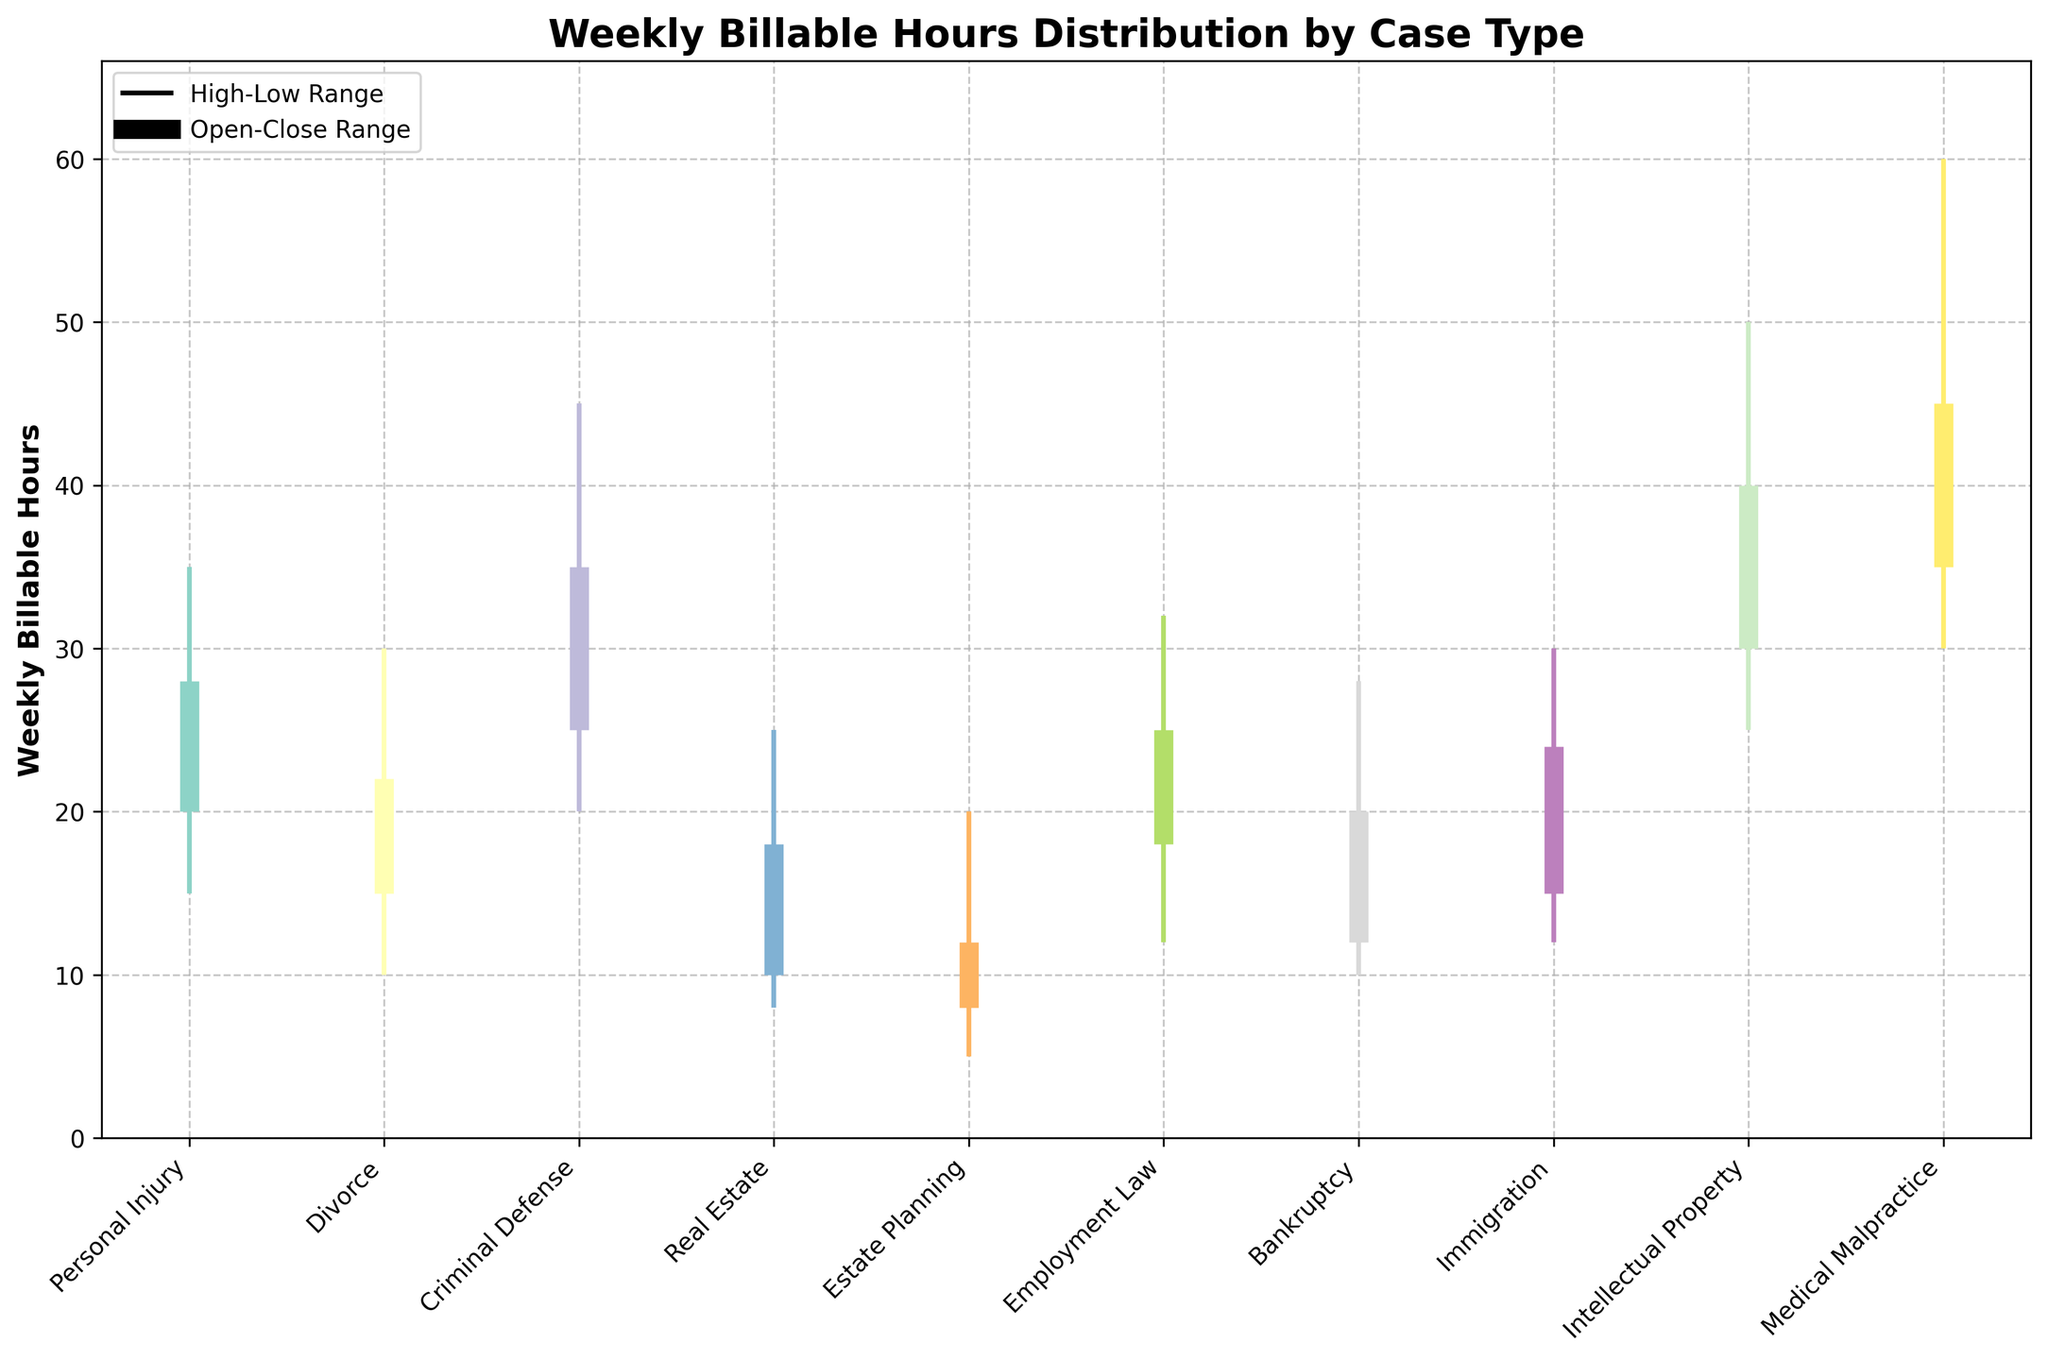What's the title of the chart? The title of the chart is written at the top of the figure. It says "Weekly Billable Hours Distribution by Case Type."
Answer: Weekly Billable Hours Distribution by Case Type What do the vertical lines represent? The vertical lines on the chart represent the range between the highest and lowest weekly billable hours for each case type. This is indicated in the legend where a line represents the high-low range.
Answer: The range between the highest and lowest hours Which case type has the highest weekly billable hours? According to the chart, the highest weekly billable hours are represented by the highest point on the vertical lines. The highest point is at 60 hours for Medical Malpractice.
Answer: Medical Malpractice How do the "open" and "close" hours compare for Personal Injury? For Personal Injury, the "open" hours are 20 and the "close" hours are 28. You can see this in the thick vertical bar representing the open-close range in the chart.
Answer: Open: 20, Close: 28 Which case type has the smallest difference between the high and low weekly billable hours? To find the smallest difference, you subtract the low from the high for each case type. Estate Planning has the smallest difference (20-5=15).
Answer: Estate Planning What is the total high weekly billable hours for Divorce and Real Estate cases? For Divorce, the high is 30 hours and for Real Estate, the high is 25 hours. Total high = 30 + 25 = 55 hours.
Answer: 55 hours Are there any cases where the weekly billable hours never drop below 10 hours? By looking at the lowest points of the vertical lines, we find that the only case types where the weekly billable hours are never below 10 are Criminal Defense (lowest point is 20), and Medical Malpractice (lowest point is 30).
Answer: Criminal Defense, Medical Malpractice What is the range of weekly billable hours for Intellectual Property cases? The low for Intellectual Property is 25 hours, and the high is 50 hours. Range = High - Low = 50 - 25 = 25 hours.
Answer: 25 hours Comparing Personal Injury and Employment Law, which has a higher close weekly billable hour value? Personal Injury has a close value of 28 hours, while Employment Law has a close value of 25 hours. Therefore, Personal Injury has a higher close value.
Answer: Personal Injury What is the average combined high value of Personal Injury, Divorce, and Criminal Defense cases? The high values are 35 for Personal Injury, 30 for Divorce, and 45 for Criminal Defense. Average = (35 + 30 + 45) / 3 = 110 / 3 = approximately 36.67 hours.
Answer: Approximately 36.67 hours 